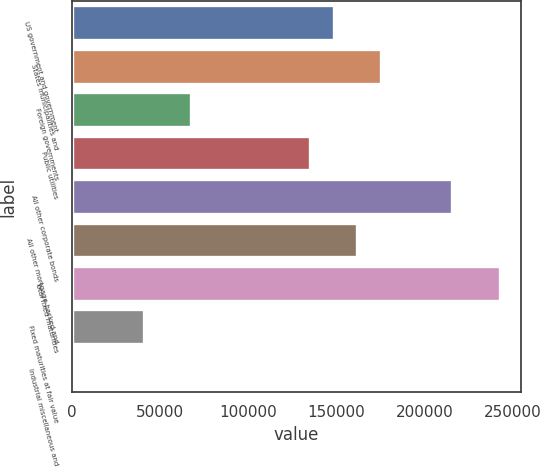Convert chart to OTSL. <chart><loc_0><loc_0><loc_500><loc_500><bar_chart><fcel>US government and government<fcel>States municipalities and<fcel>Foreign governments<fcel>Public utilities<fcel>All other corporate bonds<fcel>All other mortgage-backed and<fcel>Total fixed maturities<fcel>Fixed maturities at fair value<fcel>Industrial miscellaneous and<nl><fcel>148398<fcel>175300<fcel>67695.5<fcel>134948<fcel>215651<fcel>161849<fcel>242552<fcel>40794.5<fcel>443<nl></chart> 